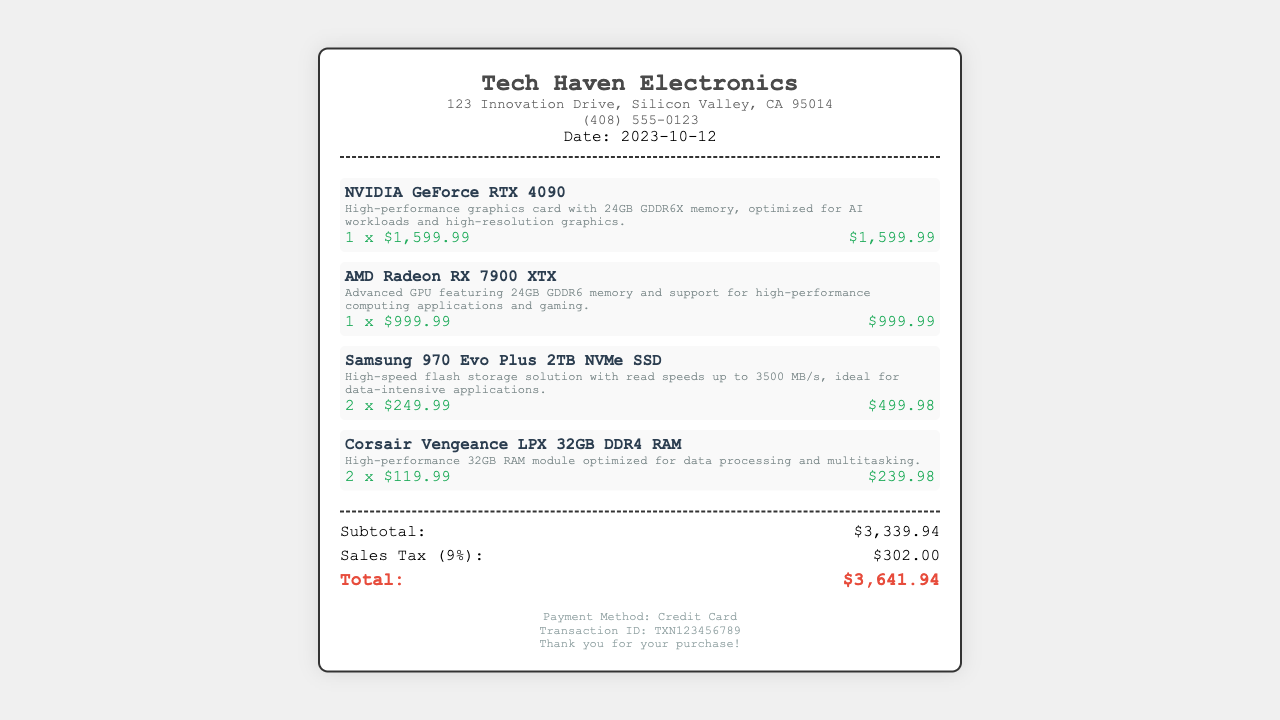What is the store name? The store name is located at the top of the receipt and is listed as Tech Haven Electronics.
Answer: Tech Haven Electronics What is the total amount paid? The total amount paid is highlighted at the end of the receipt under the 'Total' section.
Answer: $3,641.94 How many Samsung 970 Evo Plus 2TB NVMe SSDs were purchased? The quantity of Samsung 970 Evo Plus 2TB NVMe SSDs is stated next to the item in the receipt.
Answer: 2 What is the sales tax percentage? The sales tax percentage is mentioned in the receipt as a calculation of the subtotal.
Answer: 9% What date was the purchase made? The purchase date is specified in the header section of the receipt.
Answer: 2023-10-12 What is the transaction ID? The transaction ID is provided at the bottom of the receipt in the footer section.
Answer: TXN123456789 What type of payment was used? The payment method is located at the bottom of the receipt, indicating the means of payment.
Answer: Credit Card Which GPU has more memory? The document compares the memory of GPUs listed; RTX 4090 has 24GB vs. RX 7900 XTX's 24GB.
Answer: Both What is the description of the Corsair Vengeance LPX 32GB DDR4 RAM? The description of the RAM is listed right below its name in the item section.
Answer: High-performance 32GB RAM module optimized for data processing and multitasking 